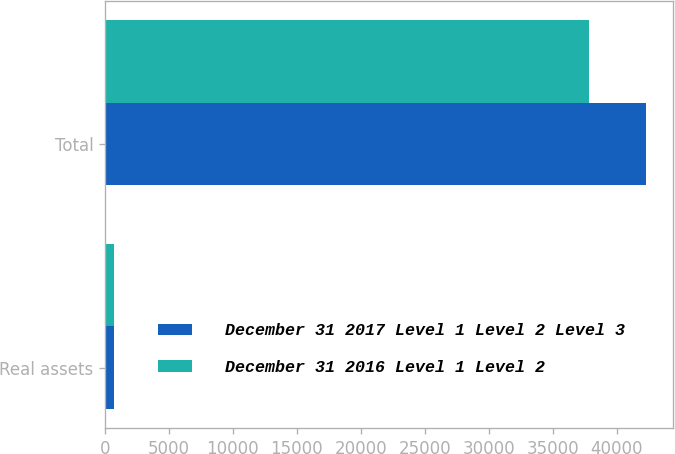Convert chart. <chart><loc_0><loc_0><loc_500><loc_500><stacked_bar_chart><ecel><fcel>Real assets<fcel>Total<nl><fcel>December 31 2017 Level 1 Level 2 Level 3<fcel>705<fcel>42305<nl><fcel>December 31 2016 Level 1 Level 2<fcel>672<fcel>37866<nl></chart> 